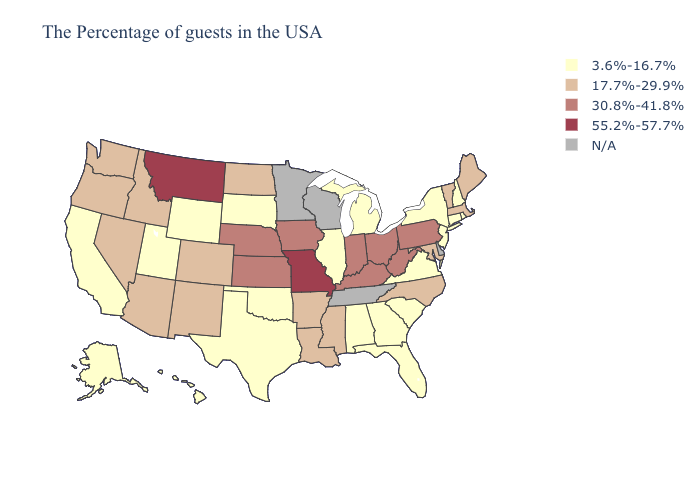Name the states that have a value in the range N/A?
Be succinct. Delaware, Tennessee, Wisconsin, Minnesota. Which states have the lowest value in the USA?
Give a very brief answer. Rhode Island, New Hampshire, Connecticut, New York, New Jersey, Virginia, South Carolina, Florida, Georgia, Michigan, Alabama, Illinois, Oklahoma, Texas, South Dakota, Wyoming, Utah, California, Alaska, Hawaii. Does Missouri have the highest value in the USA?
Concise answer only. Yes. Is the legend a continuous bar?
Give a very brief answer. No. Name the states that have a value in the range 55.2%-57.7%?
Give a very brief answer. Missouri, Montana. What is the value of Kansas?
Answer briefly. 30.8%-41.8%. Does Montana have the lowest value in the West?
Answer briefly. No. Name the states that have a value in the range 55.2%-57.7%?
Short answer required. Missouri, Montana. Does Illinois have the highest value in the MidWest?
Short answer required. No. What is the value of Massachusetts?
Be succinct. 17.7%-29.9%. Is the legend a continuous bar?
Quick response, please. No. What is the value of Massachusetts?
Concise answer only. 17.7%-29.9%. Does the first symbol in the legend represent the smallest category?
Concise answer only. Yes. What is the lowest value in the USA?
Short answer required. 3.6%-16.7%. 